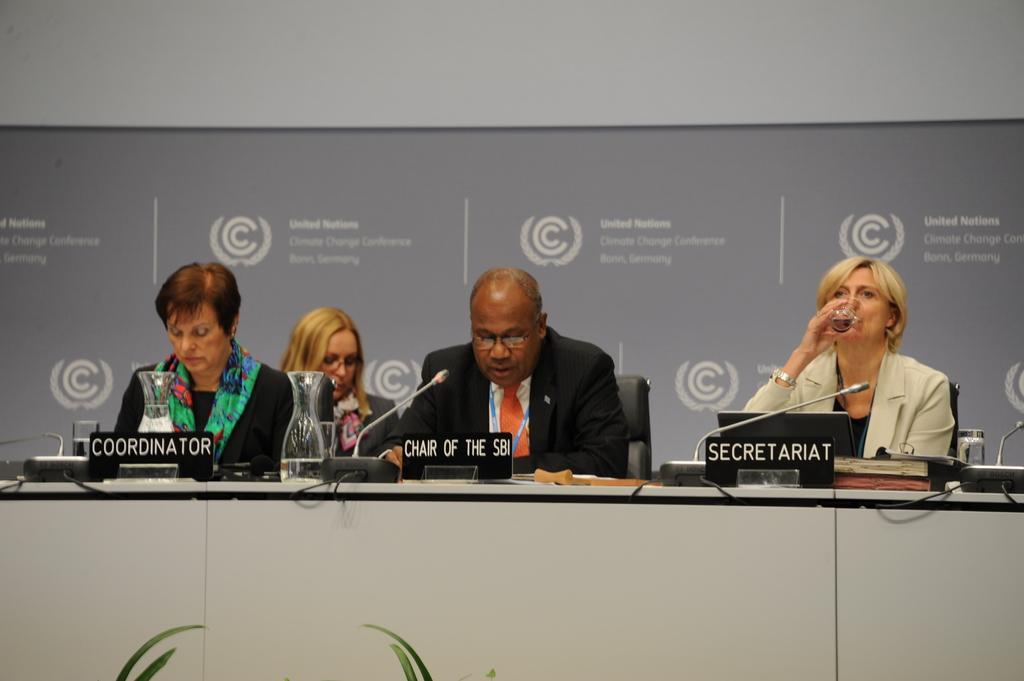Can you describe this image briefly? This picture is taken inside the room. In this image, we can see a group of people sitting on the chair in front of the table. On the table, we can see two jars, microphone, board with some text written on it, electrical wires. In the background, we can see a hoardings with some pictures and text on it. 